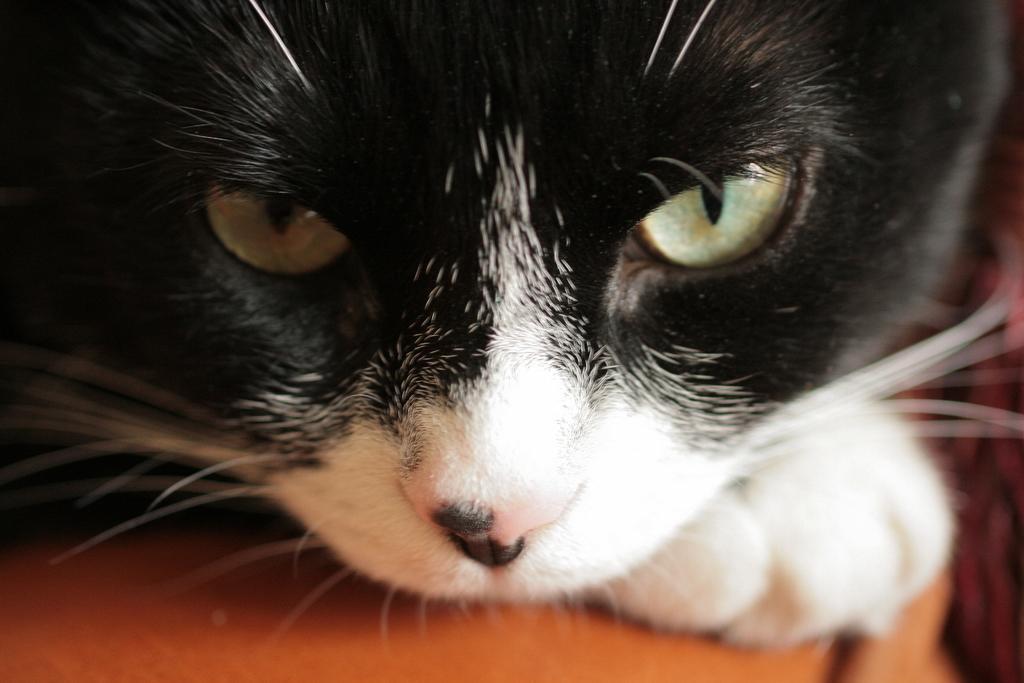Please provide a concise description of this image. In this image we can see a cat on the surface. 